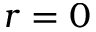<formula> <loc_0><loc_0><loc_500><loc_500>r = 0</formula> 